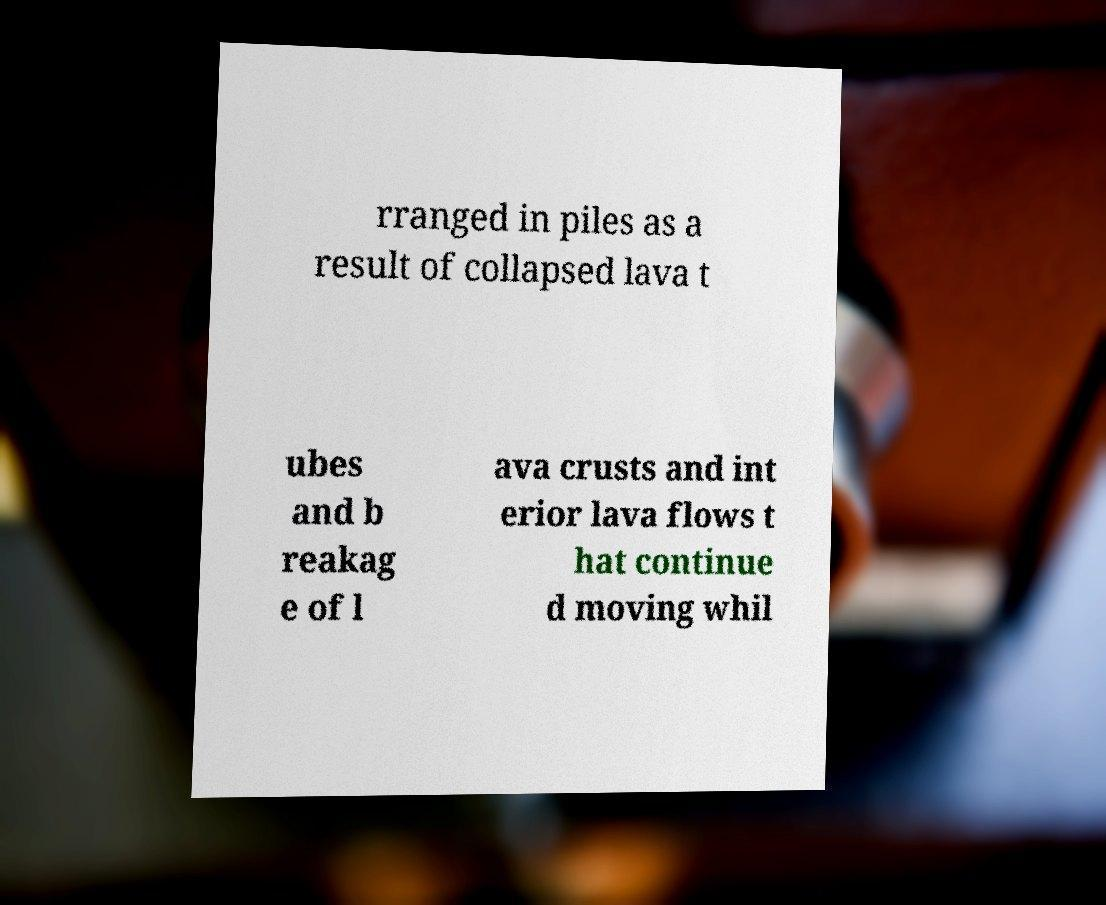Could you extract and type out the text from this image? rranged in piles as a result of collapsed lava t ubes and b reakag e of l ava crusts and int erior lava flows t hat continue d moving whil 